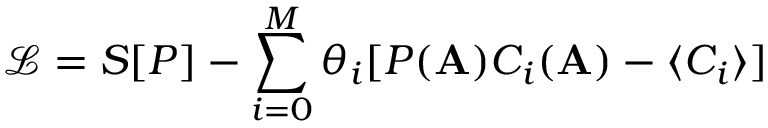<formula> <loc_0><loc_0><loc_500><loc_500>\ m a t h s c r { L } = S [ P ] - \sum _ { i = 0 } ^ { M } \theta _ { i } [ P ( A ) C _ { i } ( A ) - \langle C _ { i } \rangle ]</formula> 